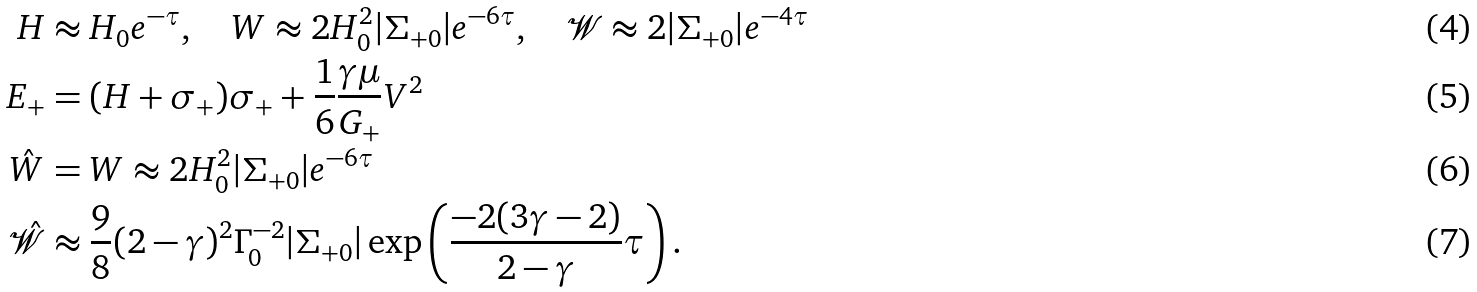<formula> <loc_0><loc_0><loc_500><loc_500>H & \approx H _ { 0 } e ^ { - \tau } , \quad W \approx 2 H _ { 0 } ^ { 2 } | \Sigma _ { + 0 } | e ^ { - 6 \tau } , \quad \mathcal { W } \approx 2 | \Sigma _ { + 0 } | e ^ { - 4 \tau } \\ E _ { + } & = ( H + \sigma _ { + } ) \sigma _ { + } + \frac { 1 } { 6 } \frac { \gamma \mu } { G _ { + } } V ^ { 2 } \\ \hat { W } & = W \approx 2 H _ { 0 } ^ { 2 } | \Sigma _ { + 0 } | e ^ { - 6 \tau } \\ \hat { \mathcal { W } } & \approx \frac { 9 } { 8 } ( 2 - \gamma ) ^ { 2 } \Gamma _ { 0 } ^ { - 2 } | \Sigma _ { + 0 } | \exp \left ( \frac { - 2 ( 3 \gamma - 2 ) } { 2 - \gamma } \tau \right ) .</formula> 